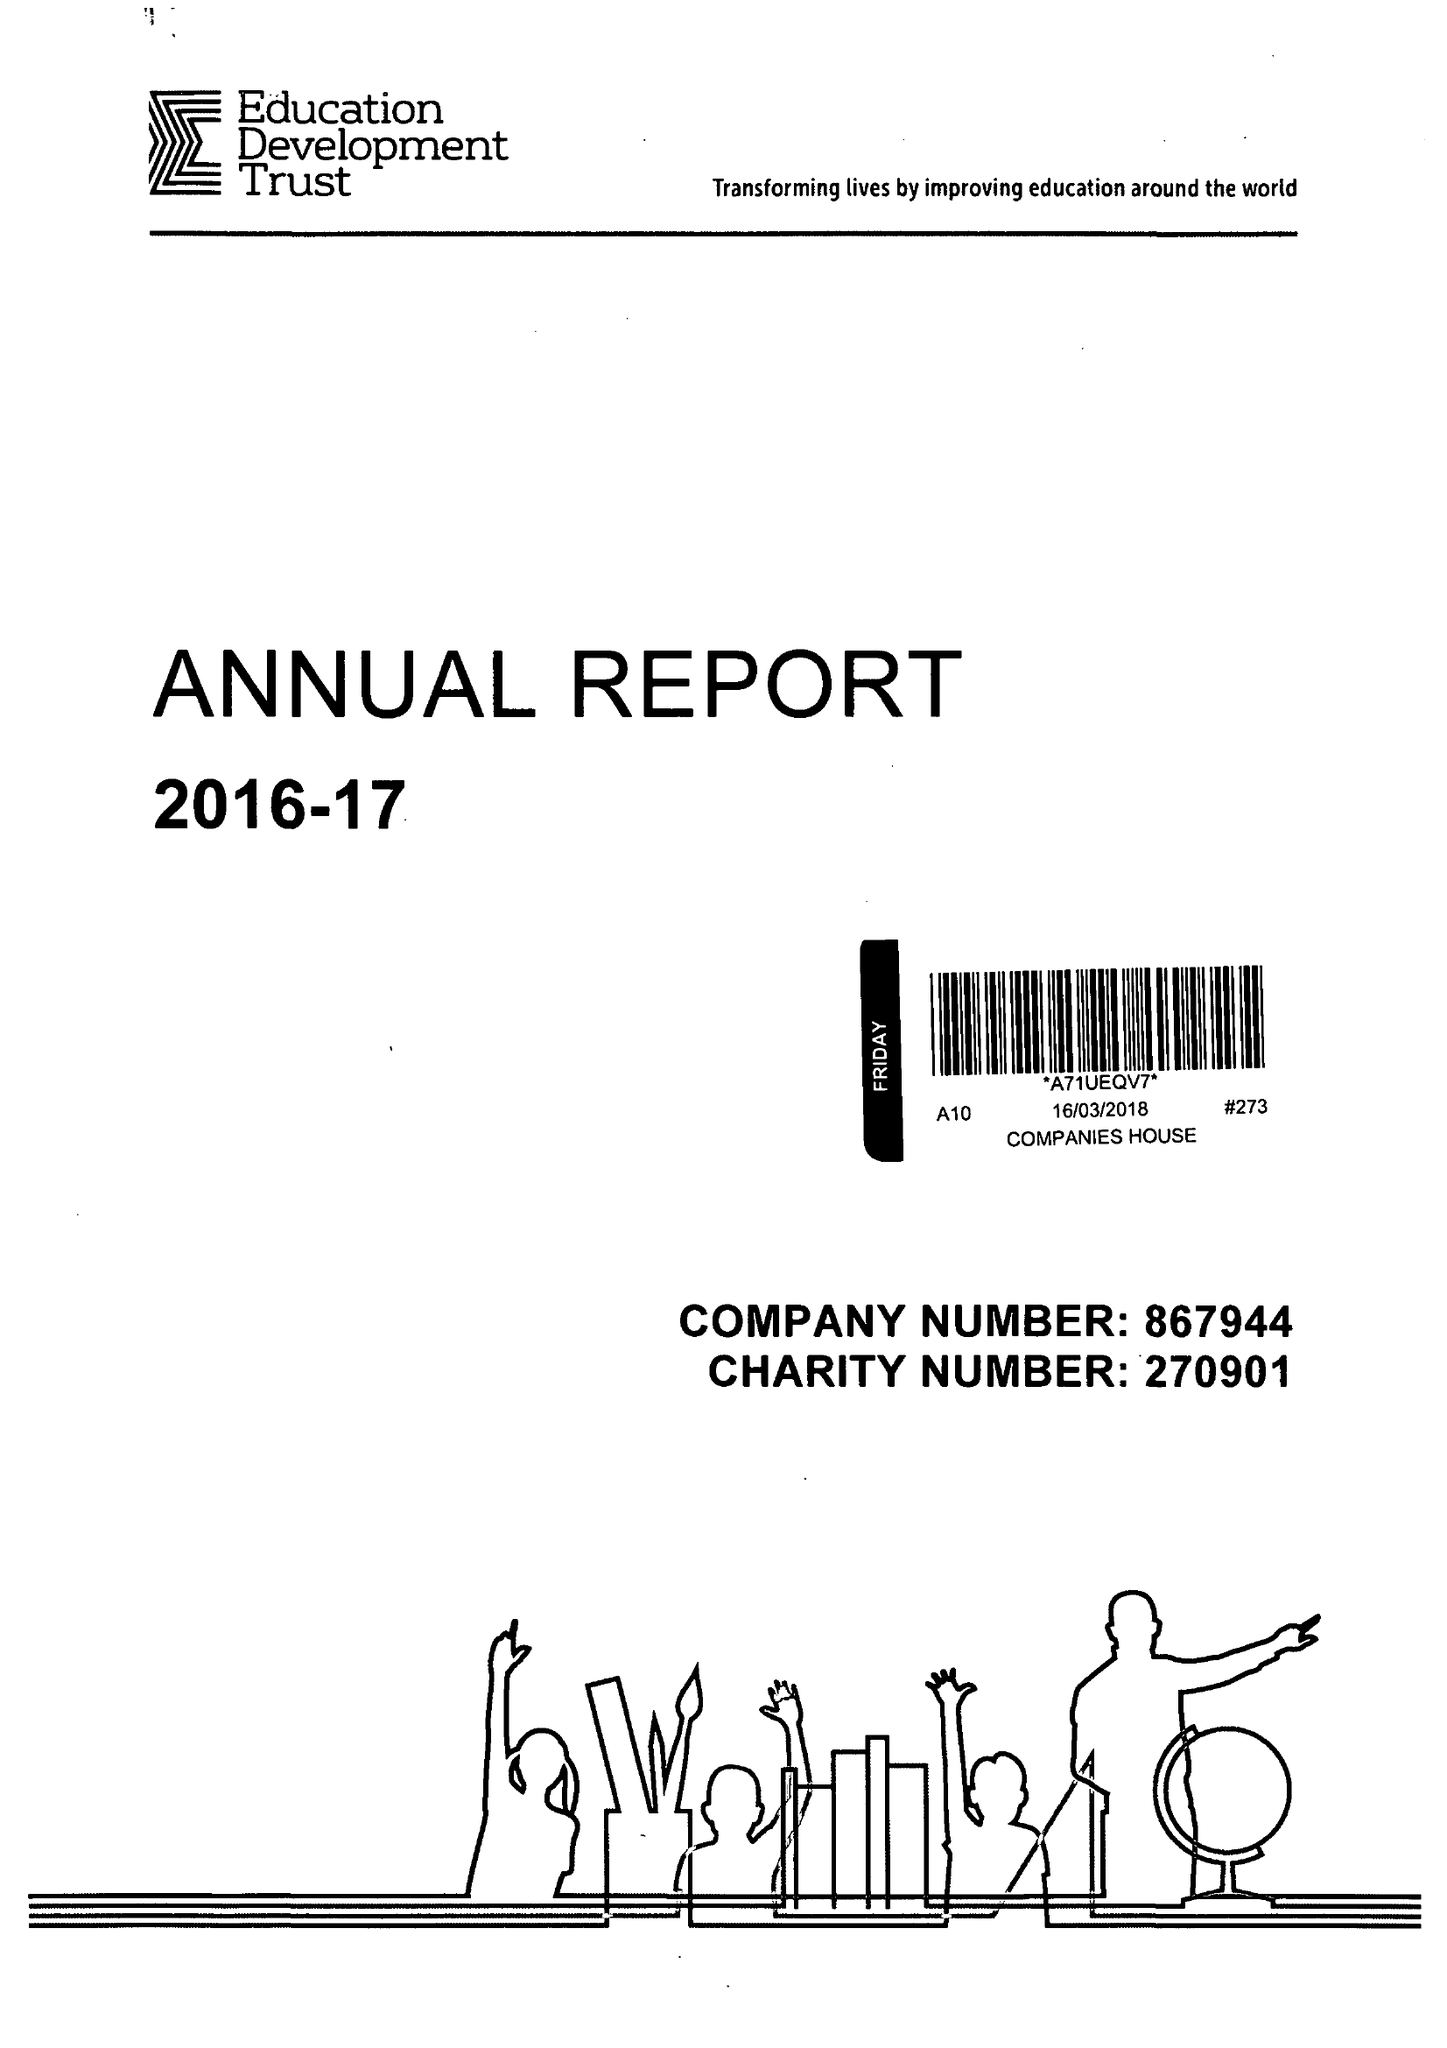What is the value for the report_date?
Answer the question using a single word or phrase. 2017-08-31 